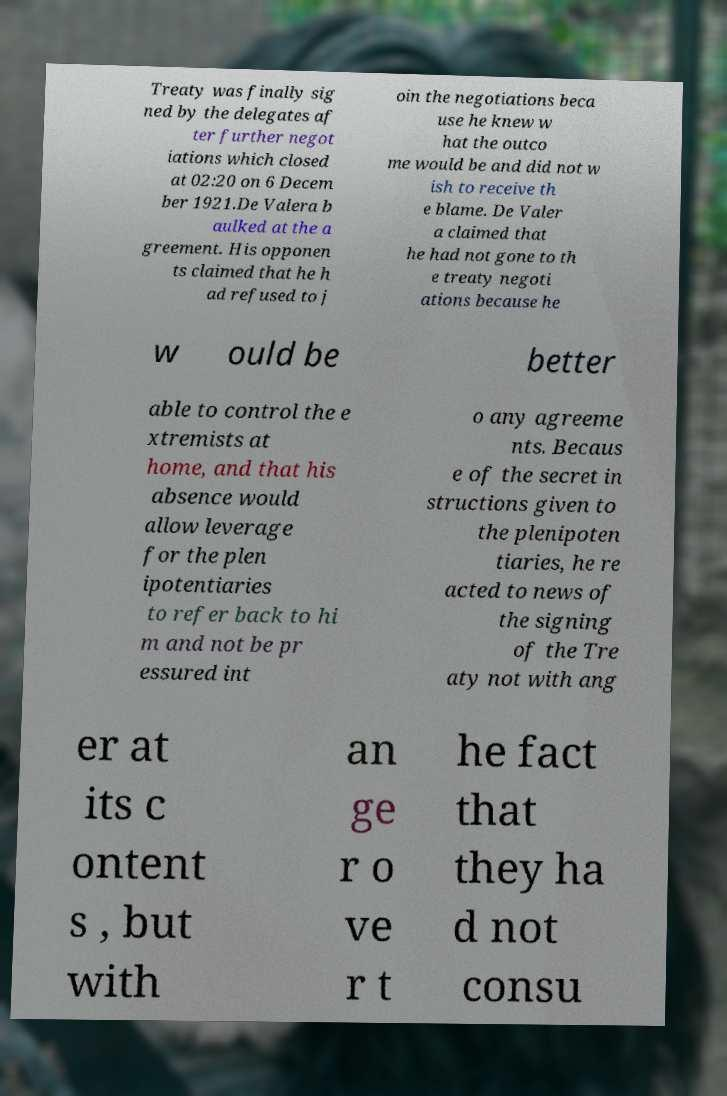Could you extract and type out the text from this image? Treaty was finally sig ned by the delegates af ter further negot iations which closed at 02:20 on 6 Decem ber 1921.De Valera b aulked at the a greement. His opponen ts claimed that he h ad refused to j oin the negotiations beca use he knew w hat the outco me would be and did not w ish to receive th e blame. De Valer a claimed that he had not gone to th e treaty negoti ations because he w ould be better able to control the e xtremists at home, and that his absence would allow leverage for the plen ipotentiaries to refer back to hi m and not be pr essured int o any agreeme nts. Becaus e of the secret in structions given to the plenipoten tiaries, he re acted to news of the signing of the Tre aty not with ang er at its c ontent s , but with an ge r o ve r t he fact that they ha d not consu 